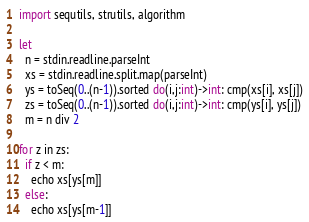<code> <loc_0><loc_0><loc_500><loc_500><_Nim_>import sequtils, strutils, algorithm

let
  n = stdin.readline.parseInt
  xs = stdin.readline.split.map(parseInt)
  ys = toSeq(0..(n-1)).sorted do(i,j:int)->int: cmp(xs[i], xs[j])
  zs = toSeq(0..(n-1)).sorted do(i,j:int)->int: cmp(ys[i], ys[j])
  m = n div 2

for z in zs:
  if z < m:
    echo xs[ys[m]]
  else:
    echo xs[ys[m-1]]
</code> 